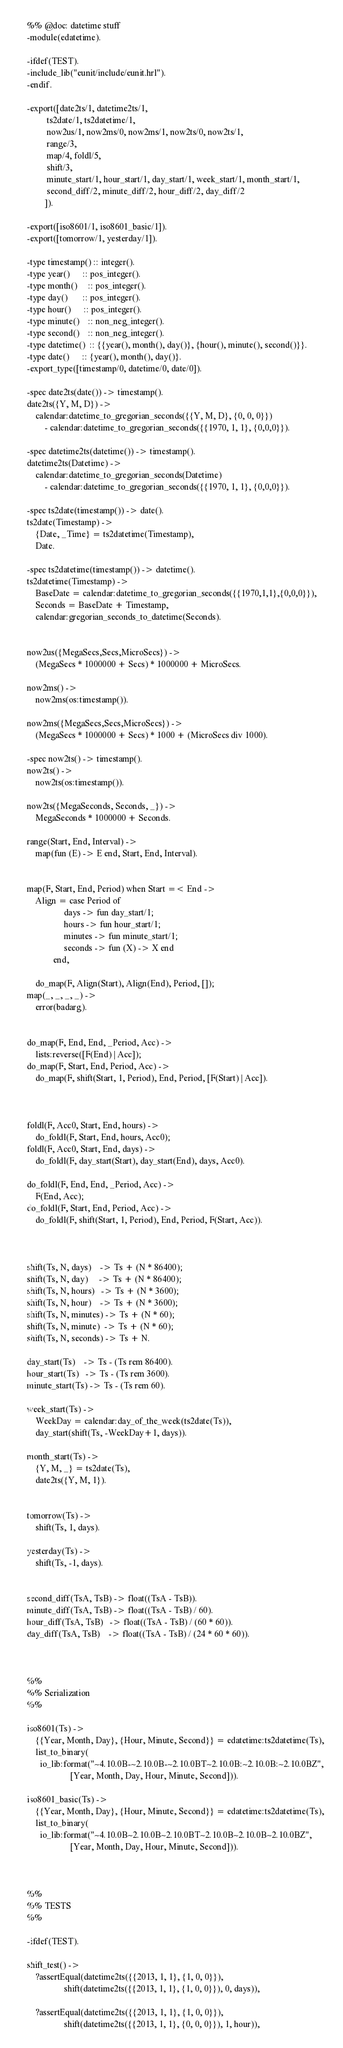<code> <loc_0><loc_0><loc_500><loc_500><_Erlang_>%% @doc: datetime stuff
-module(edatetime).

-ifdef(TEST).
-include_lib("eunit/include/eunit.hrl").
-endif.

-export([date2ts/1, datetime2ts/1,
         ts2date/1, ts2datetime/1,
         now2us/1, now2ms/0, now2ms/1, now2ts/0, now2ts/1,
         range/3,
         map/4, foldl/5,
         shift/3,
         minute_start/1, hour_start/1, day_start/1, week_start/1, month_start/1,
         second_diff/2, minute_diff/2, hour_diff/2, day_diff/2
        ]).

-export([iso8601/1, iso8601_basic/1]).
-export([tomorrow/1, yesterday/1]).

-type timestamp() :: integer().
-type year()      :: pos_integer().
-type month()     :: pos_integer().
-type day()       :: pos_integer().
-type hour()      :: pos_integer().
-type minute()    :: non_neg_integer().
-type second()    :: non_neg_integer().
-type datetime()  :: {{year(), month(), day()}, {hour(), minute(), second()}}.
-type date()      :: {year(), month(), day()}.
-export_type([timestamp/0, datetime/0, date/0]).

-spec date2ts(date()) -> timestamp().
date2ts({Y, M, D}) ->
    calendar:datetime_to_gregorian_seconds({{Y, M, D}, {0, 0, 0}})
        - calendar:datetime_to_gregorian_seconds({{1970, 1, 1}, {0,0,0}}).

-spec datetime2ts(datetime()) -> timestamp().
datetime2ts(Datetime) ->
    calendar:datetime_to_gregorian_seconds(Datetime)
        - calendar:datetime_to_gregorian_seconds({{1970, 1, 1}, {0,0,0}}).

-spec ts2date(timestamp()) -> date().
ts2date(Timestamp) ->
    {Date, _Time} = ts2datetime(Timestamp),
    Date.

-spec ts2datetime(timestamp()) -> datetime().
ts2datetime(Timestamp) ->
    BaseDate = calendar:datetime_to_gregorian_seconds({{1970,1,1},{0,0,0}}),
    Seconds = BaseDate + Timestamp,
    calendar:gregorian_seconds_to_datetime(Seconds).


now2us({MegaSecs,Secs,MicroSecs}) ->
    (MegaSecs * 1000000 + Secs) * 1000000 + MicroSecs.

now2ms() ->
    now2ms(os:timestamp()).

now2ms({MegaSecs,Secs,MicroSecs}) ->
    (MegaSecs * 1000000 + Secs) * 1000 + (MicroSecs div 1000).

-spec now2ts() -> timestamp().
now2ts() ->
    now2ts(os:timestamp()).

now2ts({MegaSeconds, Seconds, _}) ->
    MegaSeconds * 1000000 + Seconds.

range(Start, End, Interval) ->
    map(fun (E) -> E end, Start, End, Interval).


map(F, Start, End, Period) when Start =< End ->
    Align = case Period of
                 days -> fun day_start/1;
                 hours -> fun hour_start/1;
                 minutes -> fun minute_start/1;
                 seconds -> fun (X) -> X end
            end,

    do_map(F, Align(Start), Align(End), Period, []);
map(_, _, _, _) ->
    error(badarg).


do_map(F, End, End, _Period, Acc) ->
    lists:reverse([F(End) | Acc]);
do_map(F, Start, End, Period, Acc) ->
    do_map(F, shift(Start, 1, Period), End, Period, [F(Start) | Acc]).



foldl(F, Acc0, Start, End, hours) ->
    do_foldl(F, Start, End, hours, Acc0);
foldl(F, Acc0, Start, End, days) ->
    do_foldl(F, day_start(Start), day_start(End), days, Acc0).

do_foldl(F, End, End, _Period, Acc) ->
    F(End, Acc);
do_foldl(F, Start, End, Period, Acc) ->
    do_foldl(F, shift(Start, 1, Period), End, Period, F(Start, Acc)).



shift(Ts, N, days)    -> Ts + (N * 86400);
shift(Ts, N, day)     -> Ts + (N * 86400);
shift(Ts, N, hours)   -> Ts + (N * 3600);
shift(Ts, N, hour)    -> Ts + (N * 3600);
shift(Ts, N, minutes) -> Ts + (N * 60);
shift(Ts, N, minute)  -> Ts + (N * 60);
shift(Ts, N, seconds) -> Ts + N.

day_start(Ts)    -> Ts - (Ts rem 86400).
hour_start(Ts)   -> Ts - (Ts rem 3600).
minute_start(Ts) -> Ts - (Ts rem 60).

week_start(Ts) ->
    WeekDay = calendar:day_of_the_week(ts2date(Ts)),
    day_start(shift(Ts, -WeekDay+1, days)).

month_start(Ts) ->
    {Y, M, _} = ts2date(Ts),
    date2ts({Y, M, 1}).


tomorrow(Ts) ->
    shift(Ts, 1, days).

yesterday(Ts) ->
    shift(Ts, -1, days).


second_diff(TsA, TsB) -> float((TsA - TsB)).
minute_diff(TsA, TsB) -> float((TsA - TsB) / 60).
hour_diff(TsA, TsB)   -> float((TsA - TsB) / (60 * 60)).
day_diff(TsA, TsB)    -> float((TsA - TsB) / (24 * 60 * 60)).



%%
%% Serialization
%%

iso8601(Ts) ->
    {{Year, Month, Day}, {Hour, Minute, Second}} = edatetime:ts2datetime(Ts),
    list_to_binary(
      io_lib:format("~4.10.0B-~2.10.0B-~2.10.0BT~2.10.0B:~2.10.0B:~2.10.0BZ",
                    [Year, Month, Day, Hour, Minute, Second])).

iso8601_basic(Ts) ->
    {{Year, Month, Day}, {Hour, Minute, Second}} = edatetime:ts2datetime(Ts),
    list_to_binary(
      io_lib:format("~4.10.0B~2.10.0B~2.10.0BT~2.10.0B~2.10.0B~2.10.0BZ",
                    [Year, Month, Day, Hour, Minute, Second])).



%%
%% TESTS
%%

-ifdef(TEST).

shift_test() ->
    ?assertEqual(datetime2ts({{2013, 1, 1}, {1, 0, 0}}),
                 shift(datetime2ts({{2013, 1, 1}, {1, 0, 0}}), 0, days)),

    ?assertEqual(datetime2ts({{2013, 1, 1}, {1, 0, 0}}),
                 shift(datetime2ts({{2013, 1, 1}, {0, 0, 0}}), 1, hour)),
</code> 